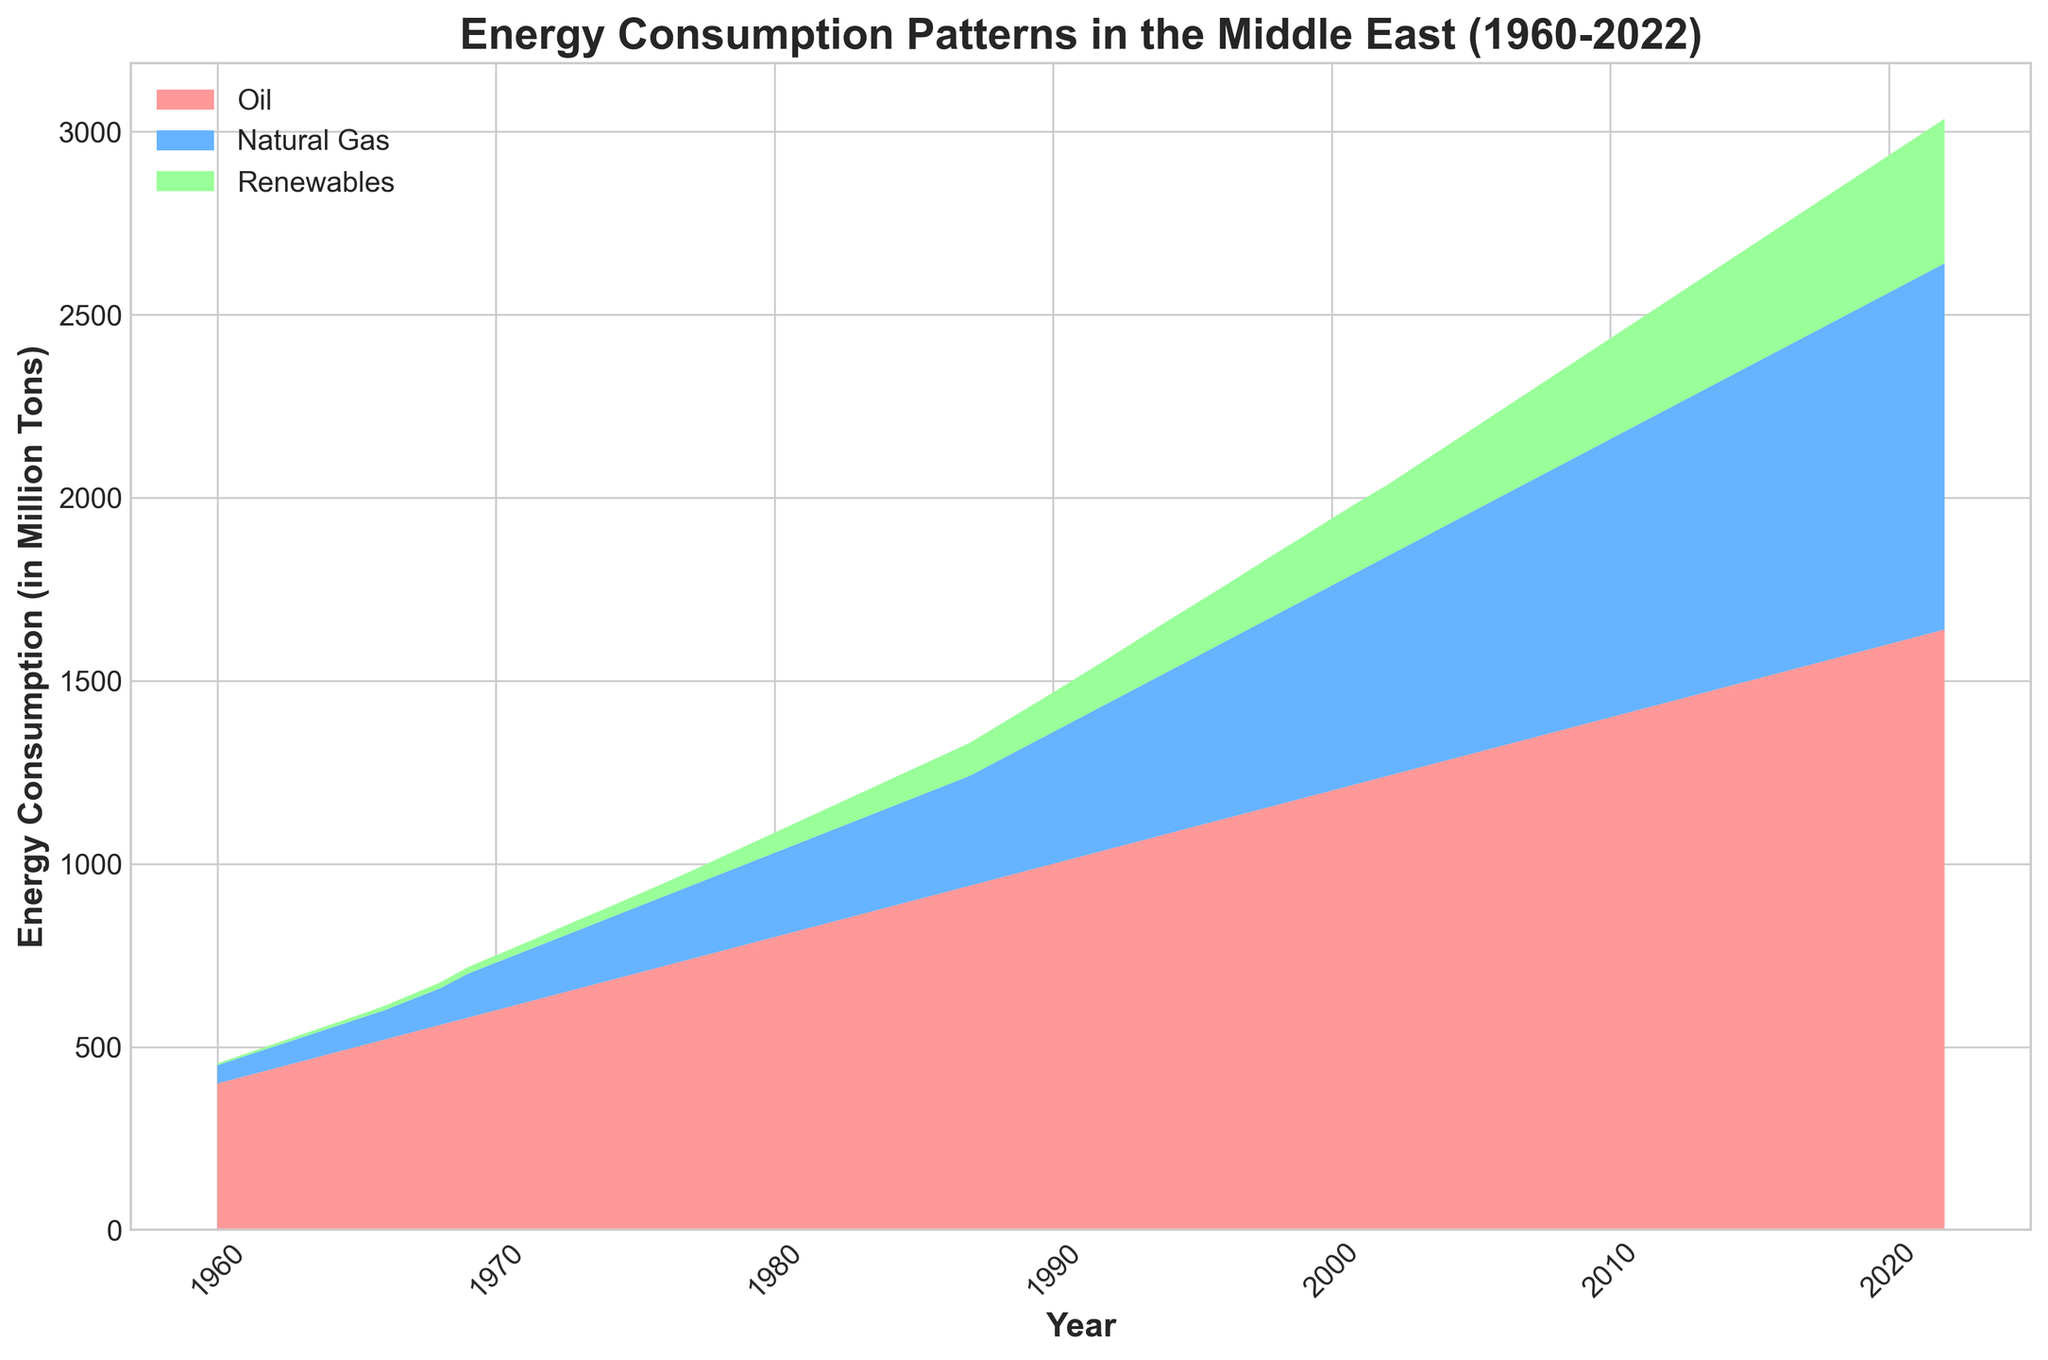What is the trend of natural gas consumption from 1960 to 2022? Observing the chart, the natural gas consumption shows a steady, continuous increase from 1960 up to 2022. It starts from a low value in 1960 and gradually rises each year until reaching its highest point in 2022.
Answer: Steady increase In which year did renewables start showing a significant upward trend? By looking at the plot's area representing renewables, they start showing a significant upward trend around 2000. Before this year, the growth is minimal and then begins accelerating significantly.
Answer: Around 2000 Comparing the energy consumption from oil and renewables in 1980, what can you conclude? In 1980, oil consumption is considerably higher than renewable energy consumption. The area covered by oil is much larger than that of renewables, indicating a big difference.
Answer: Oil was much higher Between 1960 and 1970, did oil consumption ever decline from one year to the next? Analyzing the area representing oil from 1960 to 1970, it is clear that there were no declines. The chart shows a consistent upward trajectory for oil consumption over this period.
Answer: No In which era did natural gas consumption surpass 500 million tons? Observing the blue area representing natural gas, it surpasses the 500 million ton mark around the late 1990s. The area visually indicates this transition occurs roughly before 2000.
Answer: Late 1990s How did the growth rate of renewable energy consumption change from 1960 to 2022? The chart shows slow growth in renewable energy consumption from 1960 to 2000, followed by a much steeper increase after 2000 up to 2022. Hence, the growth rate accelerated significantly after 2000.
Answer: Accelerated after 2000 What is the general comparison between oil and natural gas consumption in the 2010s? In the 2010s, oil consumption remains higher than natural gas throughout the decade. Both energy sources show increasing trends, but oil consistently covers a larger area.
Answer: Oil is higher By how much did oil consumption increase from 1960 to 2022? Oil consumption in 1960 was 400 million tons, and by 2022 it reached 1640 million tons. The increase is calculated by subtracting the 1960 value from the 2022 value, which is 1640 - 400 = 1240 million tons.
Answer: 1240 million tons During which decade did natural gas consumption increase the most rapidly? The chart indicates that natural gas saw the most rapid increase during the 1990s. The slope of the natural gas area is steepest during this period, signaling a faster rate of increase.
Answer: 1990s 